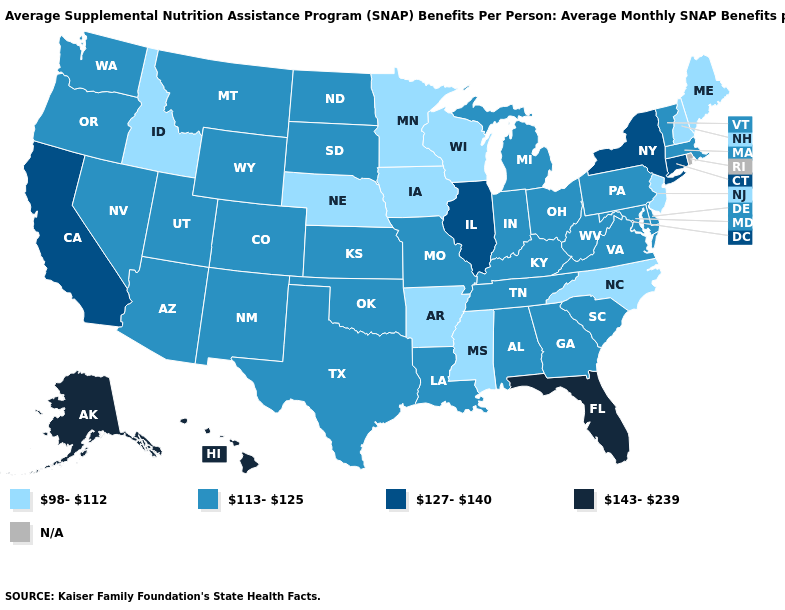Among the states that border West Virginia , which have the lowest value?
Be succinct. Kentucky, Maryland, Ohio, Pennsylvania, Virginia. Does Kansas have the highest value in the USA?
Short answer required. No. What is the value of South Dakota?
Give a very brief answer. 113-125. What is the highest value in the West ?
Short answer required. 143-239. Which states have the lowest value in the USA?
Quick response, please. Arkansas, Idaho, Iowa, Maine, Minnesota, Mississippi, Nebraska, New Hampshire, New Jersey, North Carolina, Wisconsin. What is the value of Vermont?
Keep it brief. 113-125. What is the lowest value in the West?
Be succinct. 98-112. How many symbols are there in the legend?
Write a very short answer. 5. Name the states that have a value in the range 113-125?
Short answer required. Alabama, Arizona, Colorado, Delaware, Georgia, Indiana, Kansas, Kentucky, Louisiana, Maryland, Massachusetts, Michigan, Missouri, Montana, Nevada, New Mexico, North Dakota, Ohio, Oklahoma, Oregon, Pennsylvania, South Carolina, South Dakota, Tennessee, Texas, Utah, Vermont, Virginia, Washington, West Virginia, Wyoming. What is the highest value in states that border Montana?
Short answer required. 113-125. Among the states that border Vermont , does New Hampshire have the highest value?
Be succinct. No. How many symbols are there in the legend?
Answer briefly. 5. What is the highest value in states that border Arizona?
Give a very brief answer. 127-140. Among the states that border New Jersey , which have the lowest value?
Short answer required. Delaware, Pennsylvania. 